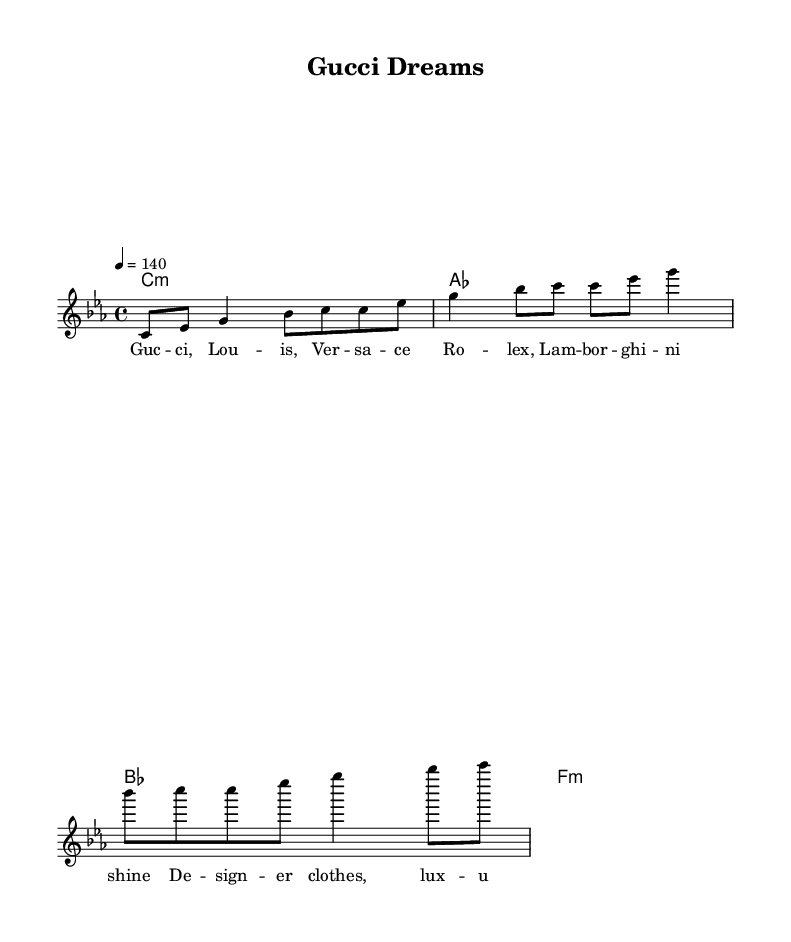What is the key signature of this music? The key signature is C minor, which consists of three flats (B♭, E♭, A♭). This is indicated at the beginning of the sheet music.
Answer: C minor What is the time signature of this piece? The time signature is indicated by the 4/4 marking at the beginning of the sheet music, meaning there are four beats per measure and the quarter note receives one beat.
Answer: 4/4 What is the marked tempo in this music? The tempo marking is indicated as 4 = 140, which means that there are 140 beats per minute for quarter notes, guiding the performance speed.
Answer: 140 How many different brands are mentioned in the lyrics? The lyrics mention five different brands: Gucci, Louis, Versace, Rolex, and Lamborghini. Counting these from the lyric line gives us this total.
Answer: 5 What type of emotional atmosphere might the harmony create in this piece? The specified chords include minor and major chords that can evoke various emotions, but the minor chords often bring a more serious or luxurious vibe, aligning with trap music themes.
Answer: Luxury Which genre does this music piece represent? While the sheet music represents a trap music style through its themes and rhythmic structure, it's explicitly categorized as a rap genre due to the lyrical content focusing on luxury lifestyles.
Answer: Rap 